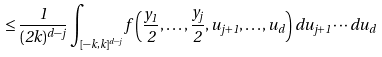Convert formula to latex. <formula><loc_0><loc_0><loc_500><loc_500>\leq \frac { 1 } { ( 2 k ) ^ { d - j } } \int _ { [ - k , k ] ^ { d - j } } f \left ( \frac { y _ { 1 } } { 2 } , \dots , \frac { y _ { j } } { 2 } , u _ { j + 1 } , \dots , u _ { d } \right ) d u _ { j + 1 } \cdots d u _ { d }</formula> 